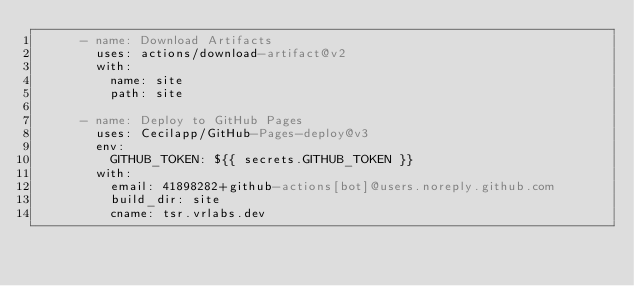Convert code to text. <code><loc_0><loc_0><loc_500><loc_500><_YAML_>      - name: Download Artifacts
        uses: actions/download-artifact@v2
        with:
          name: site
          path: site

      - name: Deploy to GitHub Pages
        uses: Cecilapp/GitHub-Pages-deploy@v3
        env:
          GITHUB_TOKEN: ${{ secrets.GITHUB_TOKEN }}
        with:
          email: 41898282+github-actions[bot]@users.noreply.github.com
          build_dir: site
          cname: tsr.vrlabs.dev</code> 